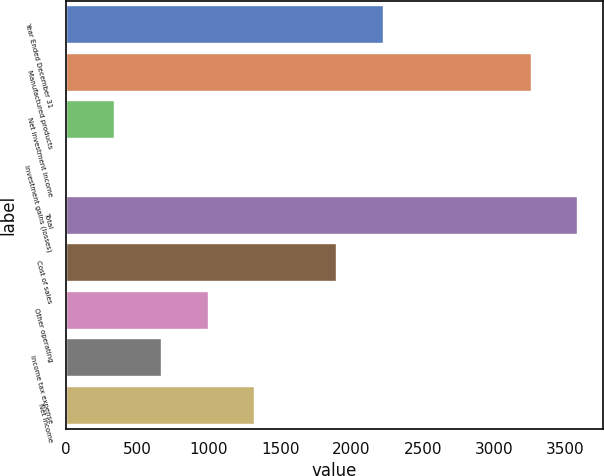<chart> <loc_0><loc_0><loc_500><loc_500><bar_chart><fcel>Year Ended December 31<fcel>Manufactured products<fcel>Net investment income<fcel>Investment gains (losses)<fcel>Total<fcel>Cost of sales<fcel>Other operating<fcel>Income tax expense<fcel>Net income<nl><fcel>2220.7<fcel>3255.6<fcel>337.3<fcel>9.7<fcel>3583.2<fcel>1893.1<fcel>992.5<fcel>664.9<fcel>1320.1<nl></chart> 